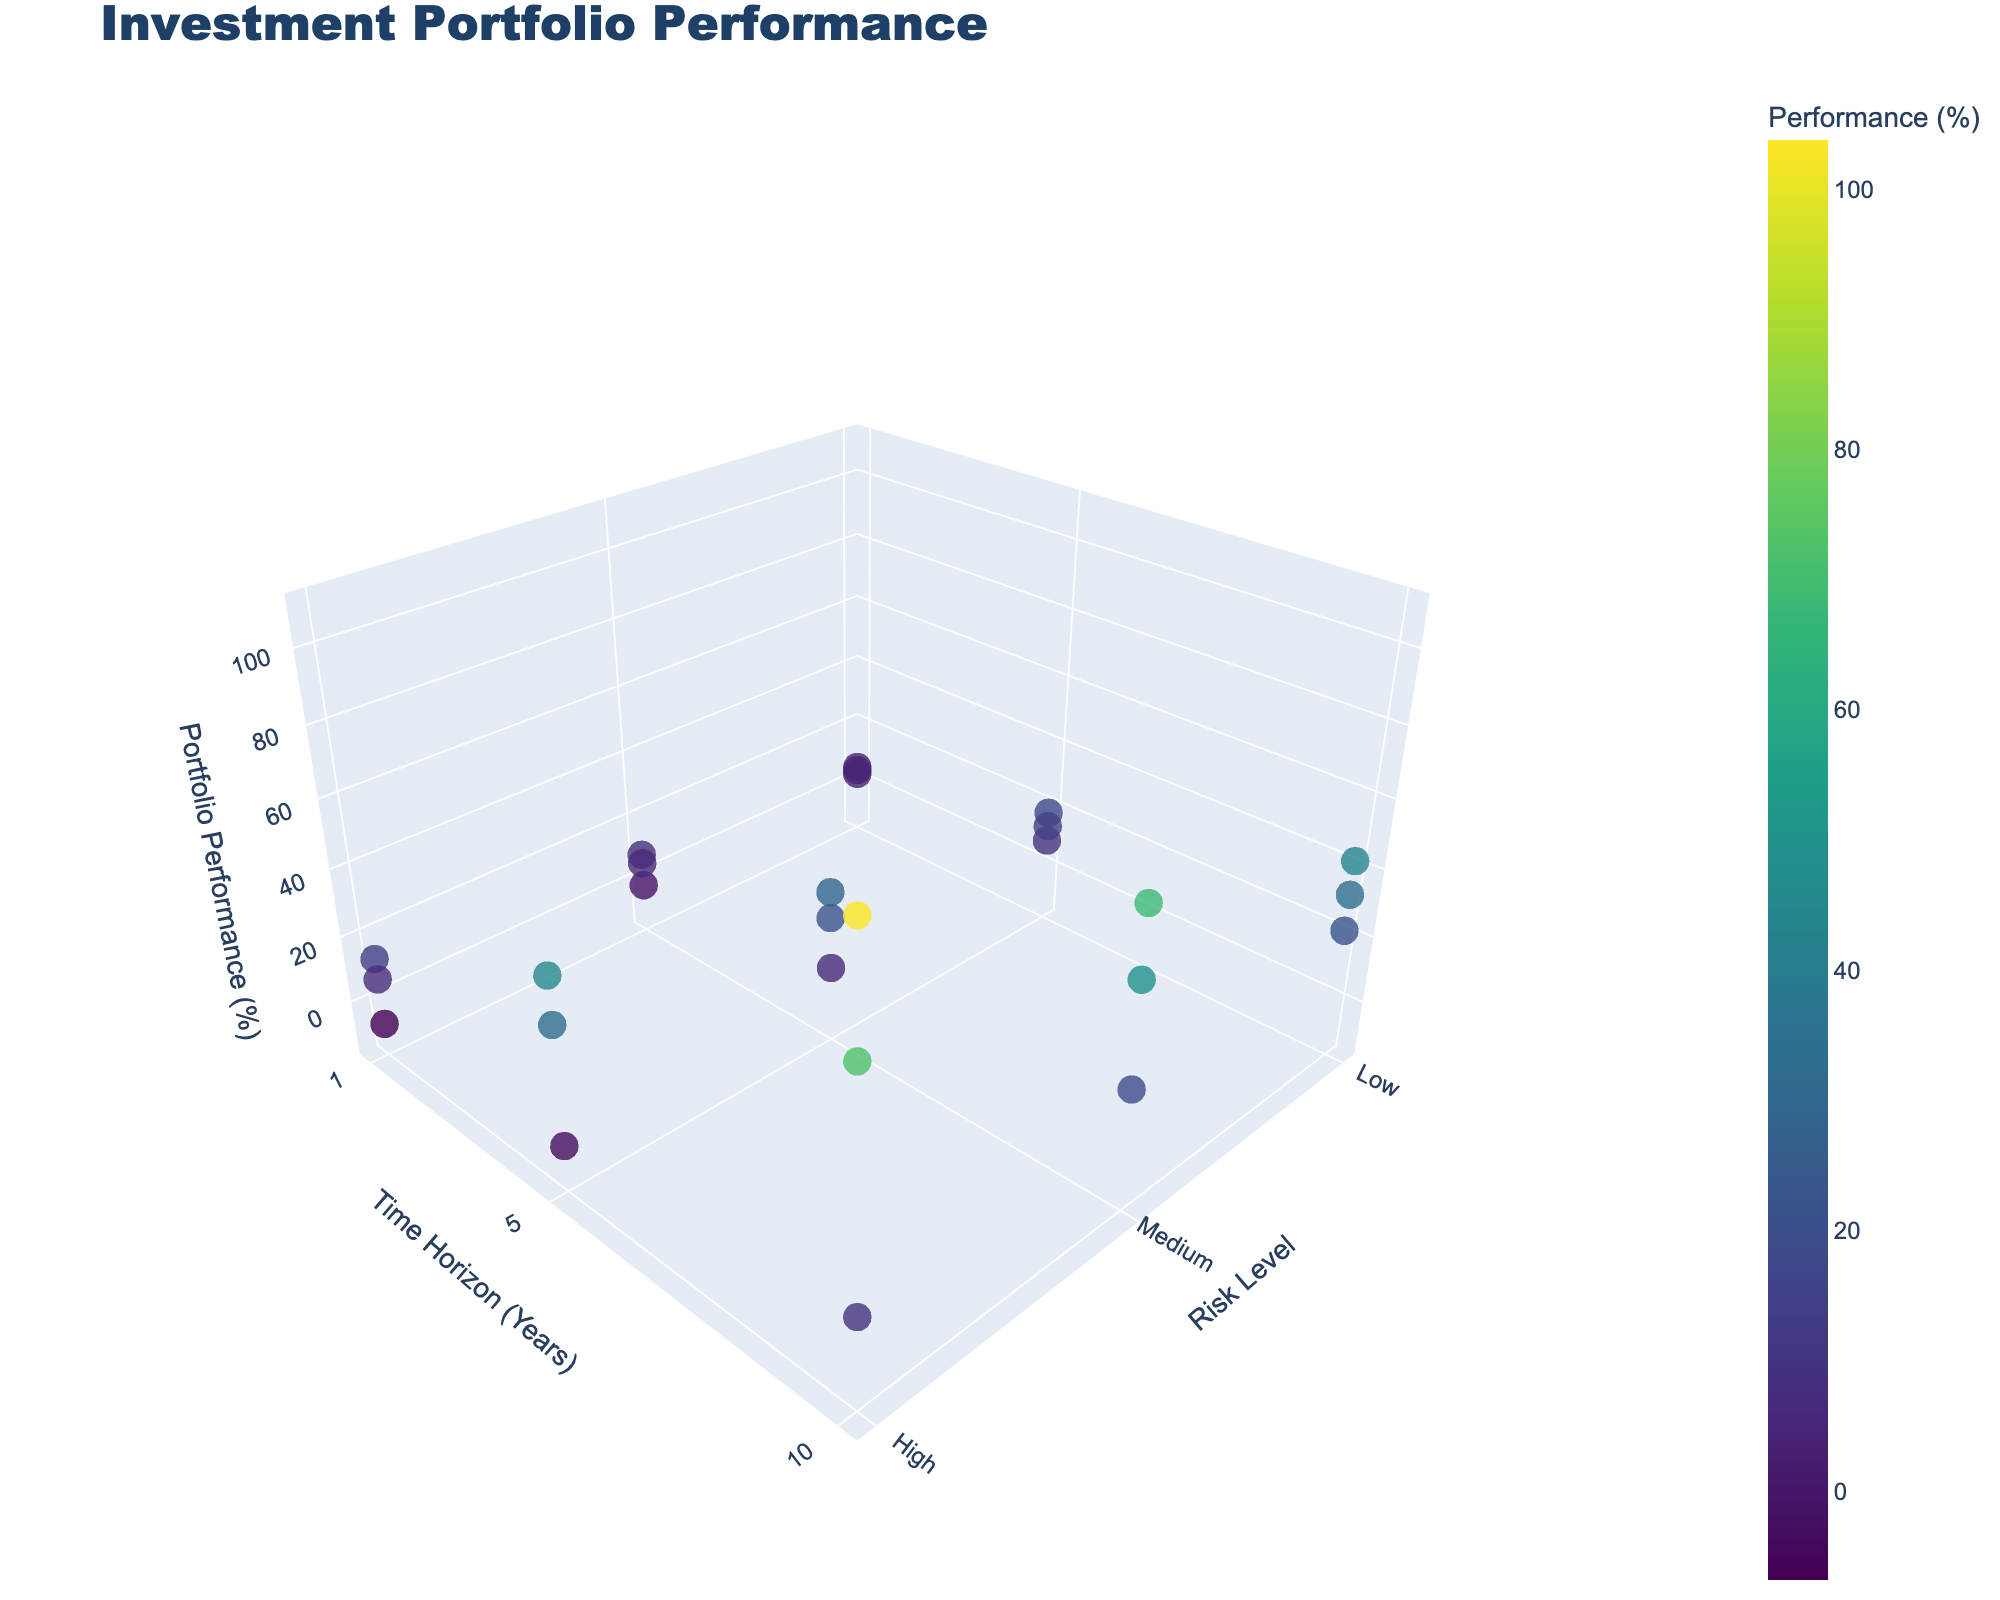What is the title of the figure? The title of the figure is displayed prominently at the top of the plot. It provides a summary of what the plot represents.
Answer: Investment Portfolio Performance What are the axis labels of the figure? The axis labels describe the dimensions of the 3D plot. The x-axis is labeled 'Risk Level', the y-axis is labeled 'Time Horizon (Years)', and the z-axis is labeled 'Portfolio Performance (%)'.
Answer: Risk Level, Time Horizon (Years), Portfolio Performance (%) How many different risk levels are shown in the plot? The x-axis represents the Risk Level, and the ticks on this axis vary, indicating the different risk levels. The risk levels shown in the plot are Low, Medium, and High.
Answer: 3 For a time horizon of 10 years under Bull market condition, which risk level has the highest portfolio performance? By examining the plot and filtering based on the y-axis (10 years) and hover text for market condition (Bull), we can compare the performances for different risk levels. The highest performance corresponds to the point at the highest z-value.
Answer: High What is the overall trend for portfolio performance as risk level increases for a time horizon of 1 year? By examining the data points along the z-axis for a time horizon of 1 year (y-axis), we can observe the change in performance from Low to Medium to High risk levels. This comparison indicates how performance varies with risk.
Answer: Increasing Which market condition shows the highest portfolio performance for a High risk level and a 5-year time horizon? By focusing on the data points where the x-axis is 'High' risk level and the y-axis is 5 years, we can identify the condition (indicated by hover text) with the highest z-value.
Answer: Bull What is the difference in portfolio performance between Medium and Low risk levels for a 10-year time horizon under Bear market conditions? Look at the points where the y-axis is 10 years, the market condition is Bear, and compare the z-values for Medium and Low risk levels. Subtract the Low performance from the Medium performance.
Answer: -3.2 (18.9 - 22.1) How does portfolio performance under Neutral market conditions vary across different time horizons for a Medium risk level? Examine the points where the x-axis is 'Medium' risk, filter by the hover text 'Neutral', and observe the change in z-values across different y-axis values (1, 5, and 10 years).
Answer: Increasing What is the portfolio performance under Bear market condition with a Low risk level and a 1-year time horizon? Locate the point where Risk Level is Low, Time Horizon is 1 year, and hover text indicates Bear Market Condition, then read the z-value.
Answer: 2.8 How does the color of the markers indicate portfolio performance in the plot? The color of the markers is determined by the color scale (Viridis) and reflects the z-values of Portfolio Performance. Darker colors represent lower performance, while lighter colors represent higher performance.
Answer: By performance 